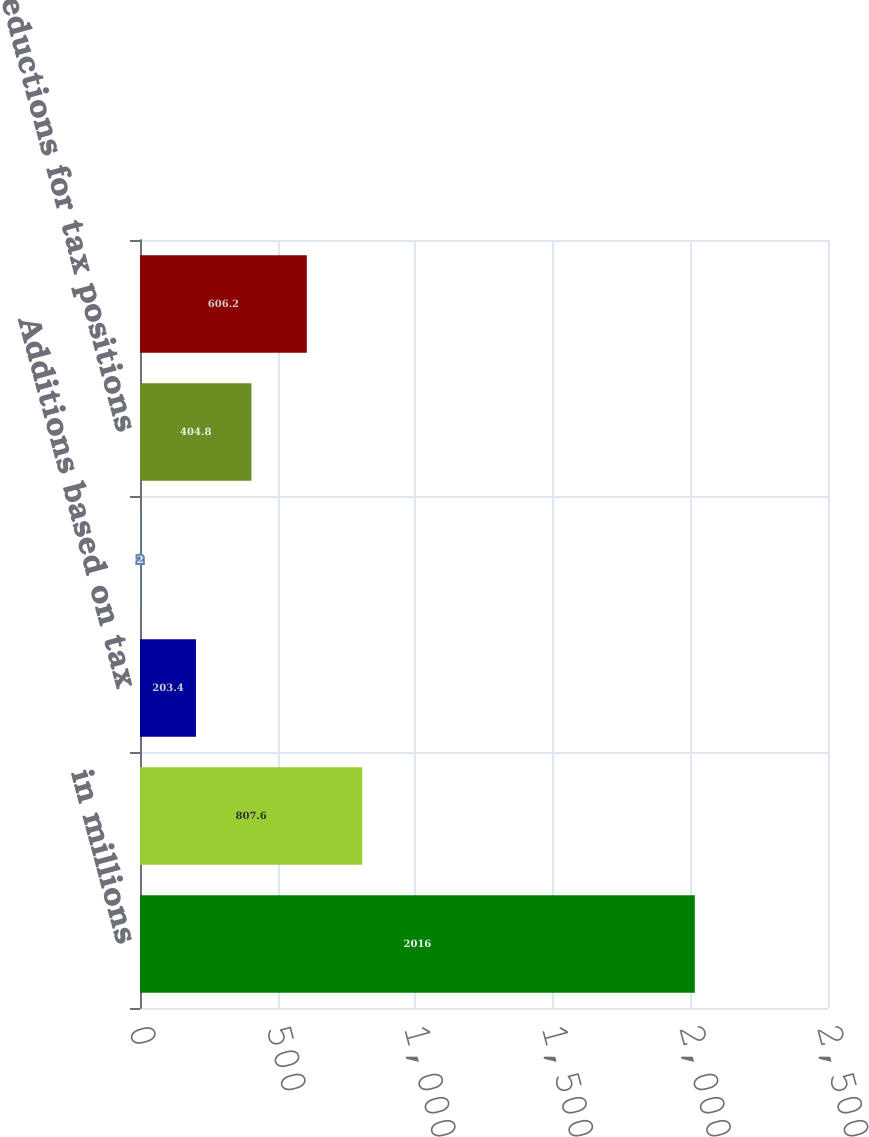<chart> <loc_0><loc_0><loc_500><loc_500><bar_chart><fcel>in millions<fcel>Unrecognized tax benefits at<fcel>Additions based on tax<fcel>Additions for tax positions of<fcel>Reductions for tax positions<fcel>Net change in unrecognized tax<nl><fcel>2016<fcel>807.6<fcel>203.4<fcel>2<fcel>404.8<fcel>606.2<nl></chart> 